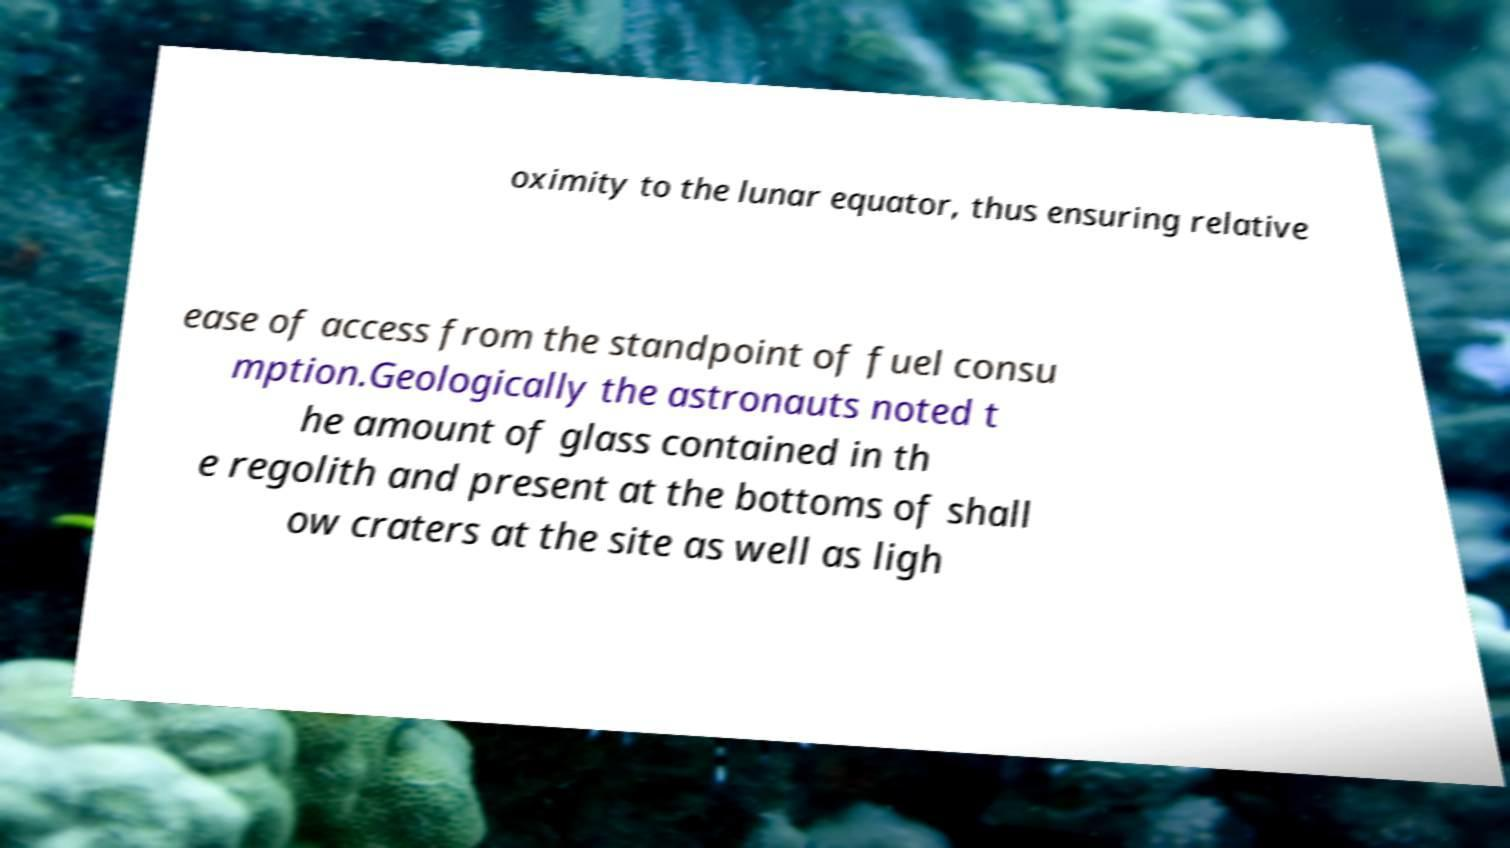Please identify and transcribe the text found in this image. oximity to the lunar equator, thus ensuring relative ease of access from the standpoint of fuel consu mption.Geologically the astronauts noted t he amount of glass contained in th e regolith and present at the bottoms of shall ow craters at the site as well as ligh 